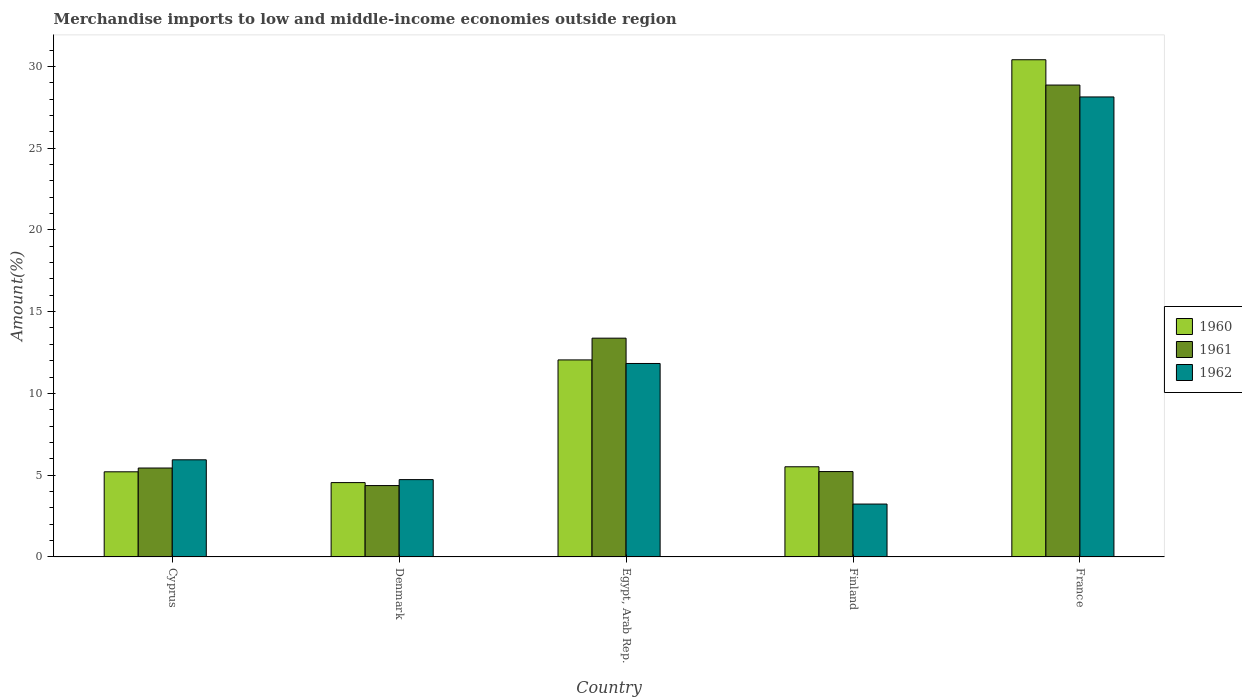How many different coloured bars are there?
Provide a succinct answer. 3. Are the number of bars per tick equal to the number of legend labels?
Your answer should be compact. Yes. How many bars are there on the 2nd tick from the right?
Offer a very short reply. 3. What is the label of the 4th group of bars from the left?
Offer a terse response. Finland. In how many cases, is the number of bars for a given country not equal to the number of legend labels?
Ensure brevity in your answer.  0. What is the percentage of amount earned from merchandise imports in 1962 in Cyprus?
Ensure brevity in your answer.  5.94. Across all countries, what is the maximum percentage of amount earned from merchandise imports in 1960?
Your answer should be very brief. 30.4. Across all countries, what is the minimum percentage of amount earned from merchandise imports in 1961?
Give a very brief answer. 4.36. In which country was the percentage of amount earned from merchandise imports in 1960 minimum?
Provide a short and direct response. Denmark. What is the total percentage of amount earned from merchandise imports in 1961 in the graph?
Your response must be concise. 57.25. What is the difference between the percentage of amount earned from merchandise imports in 1962 in Denmark and that in France?
Your answer should be compact. -23.4. What is the difference between the percentage of amount earned from merchandise imports in 1960 in Finland and the percentage of amount earned from merchandise imports in 1961 in Egypt, Arab Rep.?
Keep it short and to the point. -7.86. What is the average percentage of amount earned from merchandise imports in 1960 per country?
Offer a terse response. 11.54. What is the difference between the percentage of amount earned from merchandise imports of/in 1961 and percentage of amount earned from merchandise imports of/in 1962 in Denmark?
Your answer should be compact. -0.36. What is the ratio of the percentage of amount earned from merchandise imports in 1960 in Cyprus to that in Denmark?
Give a very brief answer. 1.15. Is the percentage of amount earned from merchandise imports in 1962 in Cyprus less than that in France?
Make the answer very short. Yes. Is the difference between the percentage of amount earned from merchandise imports in 1961 in Denmark and Egypt, Arab Rep. greater than the difference between the percentage of amount earned from merchandise imports in 1962 in Denmark and Egypt, Arab Rep.?
Your response must be concise. No. What is the difference between the highest and the second highest percentage of amount earned from merchandise imports in 1961?
Give a very brief answer. -23.42. What is the difference between the highest and the lowest percentage of amount earned from merchandise imports in 1962?
Offer a very short reply. 24.9. In how many countries, is the percentage of amount earned from merchandise imports in 1960 greater than the average percentage of amount earned from merchandise imports in 1960 taken over all countries?
Make the answer very short. 2. What does the 1st bar from the left in Finland represents?
Your answer should be compact. 1960. Is it the case that in every country, the sum of the percentage of amount earned from merchandise imports in 1962 and percentage of amount earned from merchandise imports in 1961 is greater than the percentage of amount earned from merchandise imports in 1960?
Your answer should be very brief. Yes. How many bars are there?
Ensure brevity in your answer.  15. Are all the bars in the graph horizontal?
Offer a very short reply. No. How many countries are there in the graph?
Ensure brevity in your answer.  5. Where does the legend appear in the graph?
Keep it short and to the point. Center right. How are the legend labels stacked?
Keep it short and to the point. Vertical. What is the title of the graph?
Keep it short and to the point. Merchandise imports to low and middle-income economies outside region. What is the label or title of the Y-axis?
Offer a very short reply. Amount(%). What is the Amount(%) of 1960 in Cyprus?
Give a very brief answer. 5.21. What is the Amount(%) in 1961 in Cyprus?
Give a very brief answer. 5.44. What is the Amount(%) of 1962 in Cyprus?
Provide a short and direct response. 5.94. What is the Amount(%) in 1960 in Denmark?
Give a very brief answer. 4.54. What is the Amount(%) of 1961 in Denmark?
Ensure brevity in your answer.  4.36. What is the Amount(%) in 1962 in Denmark?
Offer a very short reply. 4.73. What is the Amount(%) in 1960 in Egypt, Arab Rep.?
Your response must be concise. 12.05. What is the Amount(%) in 1961 in Egypt, Arab Rep.?
Make the answer very short. 13.38. What is the Amount(%) of 1962 in Egypt, Arab Rep.?
Your answer should be very brief. 11.83. What is the Amount(%) in 1960 in Finland?
Make the answer very short. 5.51. What is the Amount(%) of 1961 in Finland?
Your answer should be very brief. 5.22. What is the Amount(%) of 1962 in Finland?
Ensure brevity in your answer.  3.23. What is the Amount(%) in 1960 in France?
Give a very brief answer. 30.4. What is the Amount(%) in 1961 in France?
Provide a succinct answer. 28.86. What is the Amount(%) in 1962 in France?
Make the answer very short. 28.13. Across all countries, what is the maximum Amount(%) in 1960?
Provide a short and direct response. 30.4. Across all countries, what is the maximum Amount(%) in 1961?
Give a very brief answer. 28.86. Across all countries, what is the maximum Amount(%) of 1962?
Offer a terse response. 28.13. Across all countries, what is the minimum Amount(%) of 1960?
Your answer should be very brief. 4.54. Across all countries, what is the minimum Amount(%) of 1961?
Give a very brief answer. 4.36. Across all countries, what is the minimum Amount(%) in 1962?
Your response must be concise. 3.23. What is the total Amount(%) in 1960 in the graph?
Offer a terse response. 57.72. What is the total Amount(%) in 1961 in the graph?
Offer a terse response. 57.25. What is the total Amount(%) in 1962 in the graph?
Your response must be concise. 53.86. What is the difference between the Amount(%) of 1960 in Cyprus and that in Denmark?
Your answer should be very brief. 0.66. What is the difference between the Amount(%) of 1961 in Cyprus and that in Denmark?
Offer a very short reply. 1.07. What is the difference between the Amount(%) in 1962 in Cyprus and that in Denmark?
Offer a terse response. 1.21. What is the difference between the Amount(%) in 1960 in Cyprus and that in Egypt, Arab Rep.?
Ensure brevity in your answer.  -6.84. What is the difference between the Amount(%) of 1961 in Cyprus and that in Egypt, Arab Rep.?
Make the answer very short. -7.94. What is the difference between the Amount(%) in 1962 in Cyprus and that in Egypt, Arab Rep.?
Keep it short and to the point. -5.89. What is the difference between the Amount(%) of 1960 in Cyprus and that in Finland?
Give a very brief answer. -0.31. What is the difference between the Amount(%) of 1961 in Cyprus and that in Finland?
Your answer should be compact. 0.22. What is the difference between the Amount(%) in 1962 in Cyprus and that in Finland?
Keep it short and to the point. 2.71. What is the difference between the Amount(%) in 1960 in Cyprus and that in France?
Provide a succinct answer. -25.2. What is the difference between the Amount(%) in 1961 in Cyprus and that in France?
Ensure brevity in your answer.  -23.42. What is the difference between the Amount(%) in 1962 in Cyprus and that in France?
Your answer should be very brief. -22.19. What is the difference between the Amount(%) of 1960 in Denmark and that in Egypt, Arab Rep.?
Your answer should be compact. -7.5. What is the difference between the Amount(%) of 1961 in Denmark and that in Egypt, Arab Rep.?
Your response must be concise. -9.01. What is the difference between the Amount(%) of 1962 in Denmark and that in Egypt, Arab Rep.?
Give a very brief answer. -7.1. What is the difference between the Amount(%) of 1960 in Denmark and that in Finland?
Provide a succinct answer. -0.97. What is the difference between the Amount(%) in 1961 in Denmark and that in Finland?
Your response must be concise. -0.86. What is the difference between the Amount(%) of 1962 in Denmark and that in Finland?
Ensure brevity in your answer.  1.49. What is the difference between the Amount(%) in 1960 in Denmark and that in France?
Your response must be concise. -25.86. What is the difference between the Amount(%) in 1961 in Denmark and that in France?
Your answer should be very brief. -24.49. What is the difference between the Amount(%) of 1962 in Denmark and that in France?
Ensure brevity in your answer.  -23.4. What is the difference between the Amount(%) in 1960 in Egypt, Arab Rep. and that in Finland?
Your answer should be very brief. 6.54. What is the difference between the Amount(%) in 1961 in Egypt, Arab Rep. and that in Finland?
Your response must be concise. 8.16. What is the difference between the Amount(%) of 1962 in Egypt, Arab Rep. and that in Finland?
Give a very brief answer. 8.6. What is the difference between the Amount(%) of 1960 in Egypt, Arab Rep. and that in France?
Provide a short and direct response. -18.36. What is the difference between the Amount(%) of 1961 in Egypt, Arab Rep. and that in France?
Provide a succinct answer. -15.48. What is the difference between the Amount(%) in 1962 in Egypt, Arab Rep. and that in France?
Your answer should be compact. -16.3. What is the difference between the Amount(%) of 1960 in Finland and that in France?
Give a very brief answer. -24.89. What is the difference between the Amount(%) of 1961 in Finland and that in France?
Offer a terse response. -23.64. What is the difference between the Amount(%) in 1962 in Finland and that in France?
Make the answer very short. -24.9. What is the difference between the Amount(%) in 1960 in Cyprus and the Amount(%) in 1961 in Denmark?
Make the answer very short. 0.84. What is the difference between the Amount(%) of 1960 in Cyprus and the Amount(%) of 1962 in Denmark?
Your answer should be very brief. 0.48. What is the difference between the Amount(%) in 1961 in Cyprus and the Amount(%) in 1962 in Denmark?
Your answer should be very brief. 0.71. What is the difference between the Amount(%) in 1960 in Cyprus and the Amount(%) in 1961 in Egypt, Arab Rep.?
Your answer should be compact. -8.17. What is the difference between the Amount(%) in 1960 in Cyprus and the Amount(%) in 1962 in Egypt, Arab Rep.?
Provide a short and direct response. -6.62. What is the difference between the Amount(%) of 1961 in Cyprus and the Amount(%) of 1962 in Egypt, Arab Rep.?
Offer a very short reply. -6.39. What is the difference between the Amount(%) in 1960 in Cyprus and the Amount(%) in 1961 in Finland?
Give a very brief answer. -0.01. What is the difference between the Amount(%) in 1960 in Cyprus and the Amount(%) in 1962 in Finland?
Keep it short and to the point. 1.97. What is the difference between the Amount(%) in 1961 in Cyprus and the Amount(%) in 1962 in Finland?
Provide a succinct answer. 2.2. What is the difference between the Amount(%) in 1960 in Cyprus and the Amount(%) in 1961 in France?
Offer a very short reply. -23.65. What is the difference between the Amount(%) in 1960 in Cyprus and the Amount(%) in 1962 in France?
Provide a short and direct response. -22.92. What is the difference between the Amount(%) in 1961 in Cyprus and the Amount(%) in 1962 in France?
Offer a terse response. -22.69. What is the difference between the Amount(%) of 1960 in Denmark and the Amount(%) of 1961 in Egypt, Arab Rep.?
Give a very brief answer. -8.83. What is the difference between the Amount(%) in 1960 in Denmark and the Amount(%) in 1962 in Egypt, Arab Rep.?
Offer a very short reply. -7.28. What is the difference between the Amount(%) of 1961 in Denmark and the Amount(%) of 1962 in Egypt, Arab Rep.?
Ensure brevity in your answer.  -7.47. What is the difference between the Amount(%) of 1960 in Denmark and the Amount(%) of 1961 in Finland?
Ensure brevity in your answer.  -0.67. What is the difference between the Amount(%) in 1960 in Denmark and the Amount(%) in 1962 in Finland?
Make the answer very short. 1.31. What is the difference between the Amount(%) of 1961 in Denmark and the Amount(%) of 1962 in Finland?
Ensure brevity in your answer.  1.13. What is the difference between the Amount(%) of 1960 in Denmark and the Amount(%) of 1961 in France?
Ensure brevity in your answer.  -24.31. What is the difference between the Amount(%) of 1960 in Denmark and the Amount(%) of 1962 in France?
Your response must be concise. -23.58. What is the difference between the Amount(%) of 1961 in Denmark and the Amount(%) of 1962 in France?
Provide a succinct answer. -23.77. What is the difference between the Amount(%) of 1960 in Egypt, Arab Rep. and the Amount(%) of 1961 in Finland?
Your answer should be compact. 6.83. What is the difference between the Amount(%) in 1960 in Egypt, Arab Rep. and the Amount(%) in 1962 in Finland?
Offer a very short reply. 8.81. What is the difference between the Amount(%) of 1961 in Egypt, Arab Rep. and the Amount(%) of 1962 in Finland?
Ensure brevity in your answer.  10.14. What is the difference between the Amount(%) of 1960 in Egypt, Arab Rep. and the Amount(%) of 1961 in France?
Offer a very short reply. -16.81. What is the difference between the Amount(%) of 1960 in Egypt, Arab Rep. and the Amount(%) of 1962 in France?
Give a very brief answer. -16.08. What is the difference between the Amount(%) in 1961 in Egypt, Arab Rep. and the Amount(%) in 1962 in France?
Make the answer very short. -14.75. What is the difference between the Amount(%) in 1960 in Finland and the Amount(%) in 1961 in France?
Your answer should be compact. -23.34. What is the difference between the Amount(%) in 1960 in Finland and the Amount(%) in 1962 in France?
Your response must be concise. -22.62. What is the difference between the Amount(%) of 1961 in Finland and the Amount(%) of 1962 in France?
Your answer should be very brief. -22.91. What is the average Amount(%) of 1960 per country?
Your answer should be very brief. 11.54. What is the average Amount(%) of 1961 per country?
Your answer should be very brief. 11.45. What is the average Amount(%) of 1962 per country?
Provide a succinct answer. 10.77. What is the difference between the Amount(%) of 1960 and Amount(%) of 1961 in Cyprus?
Keep it short and to the point. -0.23. What is the difference between the Amount(%) of 1960 and Amount(%) of 1962 in Cyprus?
Keep it short and to the point. -0.73. What is the difference between the Amount(%) of 1961 and Amount(%) of 1962 in Cyprus?
Give a very brief answer. -0.5. What is the difference between the Amount(%) in 1960 and Amount(%) in 1961 in Denmark?
Provide a short and direct response. 0.18. What is the difference between the Amount(%) in 1960 and Amount(%) in 1962 in Denmark?
Offer a terse response. -0.18. What is the difference between the Amount(%) in 1961 and Amount(%) in 1962 in Denmark?
Your answer should be very brief. -0.36. What is the difference between the Amount(%) in 1960 and Amount(%) in 1961 in Egypt, Arab Rep.?
Offer a terse response. -1.33. What is the difference between the Amount(%) in 1960 and Amount(%) in 1962 in Egypt, Arab Rep.?
Your answer should be compact. 0.22. What is the difference between the Amount(%) of 1961 and Amount(%) of 1962 in Egypt, Arab Rep.?
Your response must be concise. 1.55. What is the difference between the Amount(%) in 1960 and Amount(%) in 1961 in Finland?
Your answer should be very brief. 0.29. What is the difference between the Amount(%) in 1960 and Amount(%) in 1962 in Finland?
Make the answer very short. 2.28. What is the difference between the Amount(%) of 1961 and Amount(%) of 1962 in Finland?
Provide a succinct answer. 1.99. What is the difference between the Amount(%) in 1960 and Amount(%) in 1961 in France?
Give a very brief answer. 1.55. What is the difference between the Amount(%) of 1960 and Amount(%) of 1962 in France?
Provide a succinct answer. 2.28. What is the difference between the Amount(%) of 1961 and Amount(%) of 1962 in France?
Provide a short and direct response. 0.73. What is the ratio of the Amount(%) in 1960 in Cyprus to that in Denmark?
Provide a short and direct response. 1.15. What is the ratio of the Amount(%) of 1961 in Cyprus to that in Denmark?
Give a very brief answer. 1.25. What is the ratio of the Amount(%) in 1962 in Cyprus to that in Denmark?
Make the answer very short. 1.26. What is the ratio of the Amount(%) of 1960 in Cyprus to that in Egypt, Arab Rep.?
Offer a terse response. 0.43. What is the ratio of the Amount(%) of 1961 in Cyprus to that in Egypt, Arab Rep.?
Give a very brief answer. 0.41. What is the ratio of the Amount(%) in 1962 in Cyprus to that in Egypt, Arab Rep.?
Make the answer very short. 0.5. What is the ratio of the Amount(%) of 1960 in Cyprus to that in Finland?
Offer a very short reply. 0.94. What is the ratio of the Amount(%) in 1961 in Cyprus to that in Finland?
Provide a succinct answer. 1.04. What is the ratio of the Amount(%) in 1962 in Cyprus to that in Finland?
Provide a short and direct response. 1.84. What is the ratio of the Amount(%) of 1960 in Cyprus to that in France?
Offer a terse response. 0.17. What is the ratio of the Amount(%) in 1961 in Cyprus to that in France?
Provide a succinct answer. 0.19. What is the ratio of the Amount(%) of 1962 in Cyprus to that in France?
Give a very brief answer. 0.21. What is the ratio of the Amount(%) of 1960 in Denmark to that in Egypt, Arab Rep.?
Your response must be concise. 0.38. What is the ratio of the Amount(%) in 1961 in Denmark to that in Egypt, Arab Rep.?
Your answer should be compact. 0.33. What is the ratio of the Amount(%) of 1962 in Denmark to that in Egypt, Arab Rep.?
Your answer should be compact. 0.4. What is the ratio of the Amount(%) of 1960 in Denmark to that in Finland?
Give a very brief answer. 0.82. What is the ratio of the Amount(%) of 1961 in Denmark to that in Finland?
Give a very brief answer. 0.84. What is the ratio of the Amount(%) of 1962 in Denmark to that in Finland?
Give a very brief answer. 1.46. What is the ratio of the Amount(%) of 1960 in Denmark to that in France?
Your response must be concise. 0.15. What is the ratio of the Amount(%) of 1961 in Denmark to that in France?
Your answer should be compact. 0.15. What is the ratio of the Amount(%) in 1962 in Denmark to that in France?
Offer a very short reply. 0.17. What is the ratio of the Amount(%) in 1960 in Egypt, Arab Rep. to that in Finland?
Provide a short and direct response. 2.19. What is the ratio of the Amount(%) of 1961 in Egypt, Arab Rep. to that in Finland?
Ensure brevity in your answer.  2.56. What is the ratio of the Amount(%) in 1962 in Egypt, Arab Rep. to that in Finland?
Offer a terse response. 3.66. What is the ratio of the Amount(%) in 1960 in Egypt, Arab Rep. to that in France?
Your answer should be compact. 0.4. What is the ratio of the Amount(%) in 1961 in Egypt, Arab Rep. to that in France?
Offer a very short reply. 0.46. What is the ratio of the Amount(%) of 1962 in Egypt, Arab Rep. to that in France?
Offer a very short reply. 0.42. What is the ratio of the Amount(%) of 1960 in Finland to that in France?
Provide a short and direct response. 0.18. What is the ratio of the Amount(%) in 1961 in Finland to that in France?
Provide a short and direct response. 0.18. What is the ratio of the Amount(%) of 1962 in Finland to that in France?
Give a very brief answer. 0.11. What is the difference between the highest and the second highest Amount(%) in 1960?
Your response must be concise. 18.36. What is the difference between the highest and the second highest Amount(%) in 1961?
Provide a short and direct response. 15.48. What is the difference between the highest and the second highest Amount(%) in 1962?
Your answer should be compact. 16.3. What is the difference between the highest and the lowest Amount(%) of 1960?
Provide a short and direct response. 25.86. What is the difference between the highest and the lowest Amount(%) of 1961?
Provide a succinct answer. 24.49. What is the difference between the highest and the lowest Amount(%) of 1962?
Offer a very short reply. 24.9. 